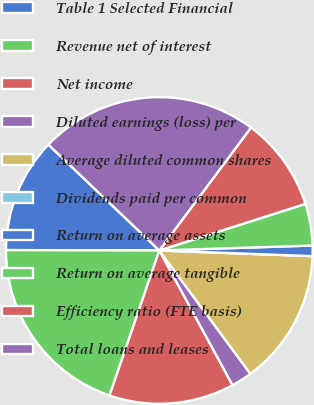<chart> <loc_0><loc_0><loc_500><loc_500><pie_chart><fcel>Table 1 Selected Financial<fcel>Revenue net of interest<fcel>Net income<fcel>Diluted earnings (loss) per<fcel>Average diluted common shares<fcel>Dividends paid per common<fcel>Return on average assets<fcel>Return on average tangible<fcel>Efficiency ratio (FTE basis)<fcel>Total loans and leases<nl><fcel>12.09%<fcel>19.78%<fcel>13.19%<fcel>2.2%<fcel>14.29%<fcel>0.0%<fcel>1.1%<fcel>4.4%<fcel>9.89%<fcel>23.08%<nl></chart> 